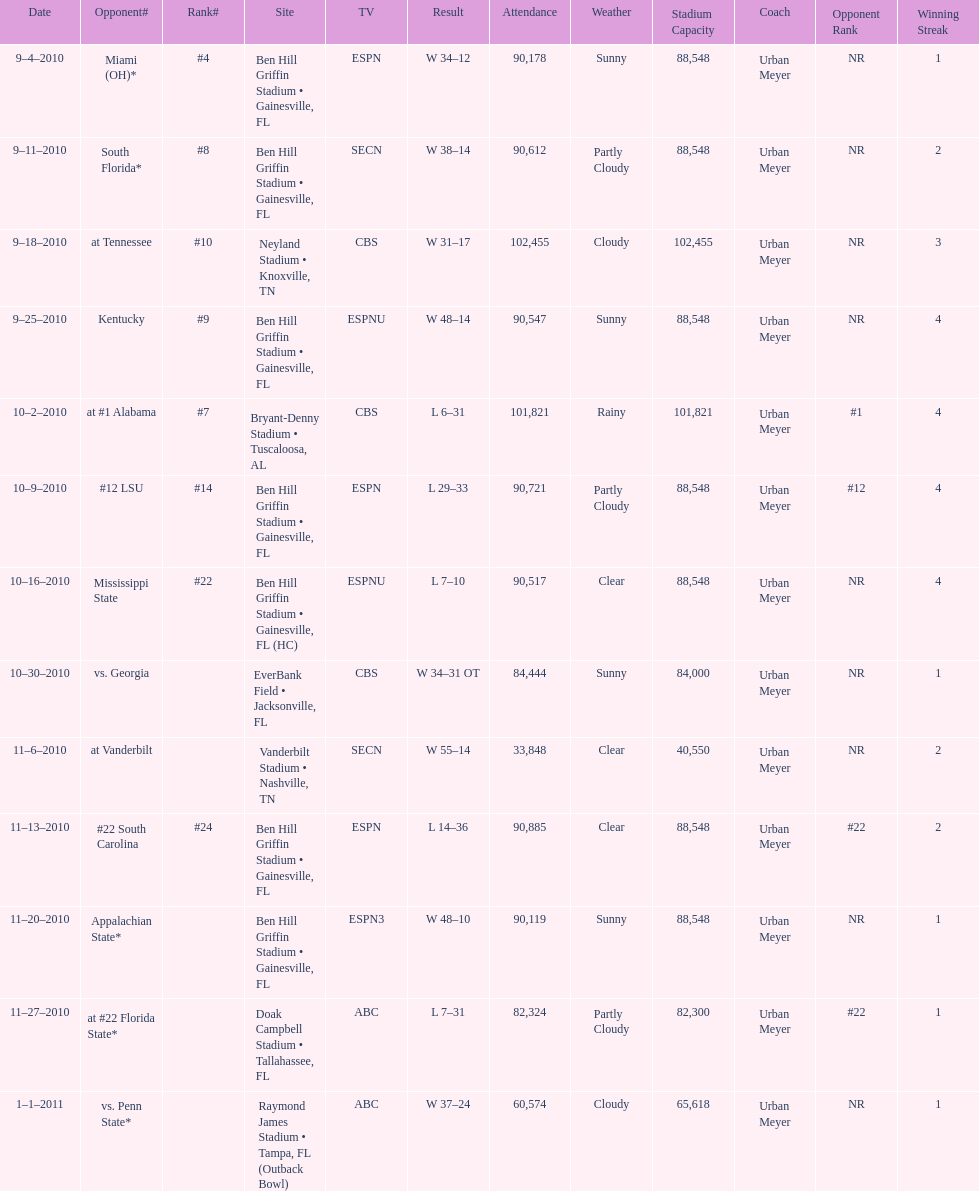What was the difference between the two scores of the last game? 13 points. 